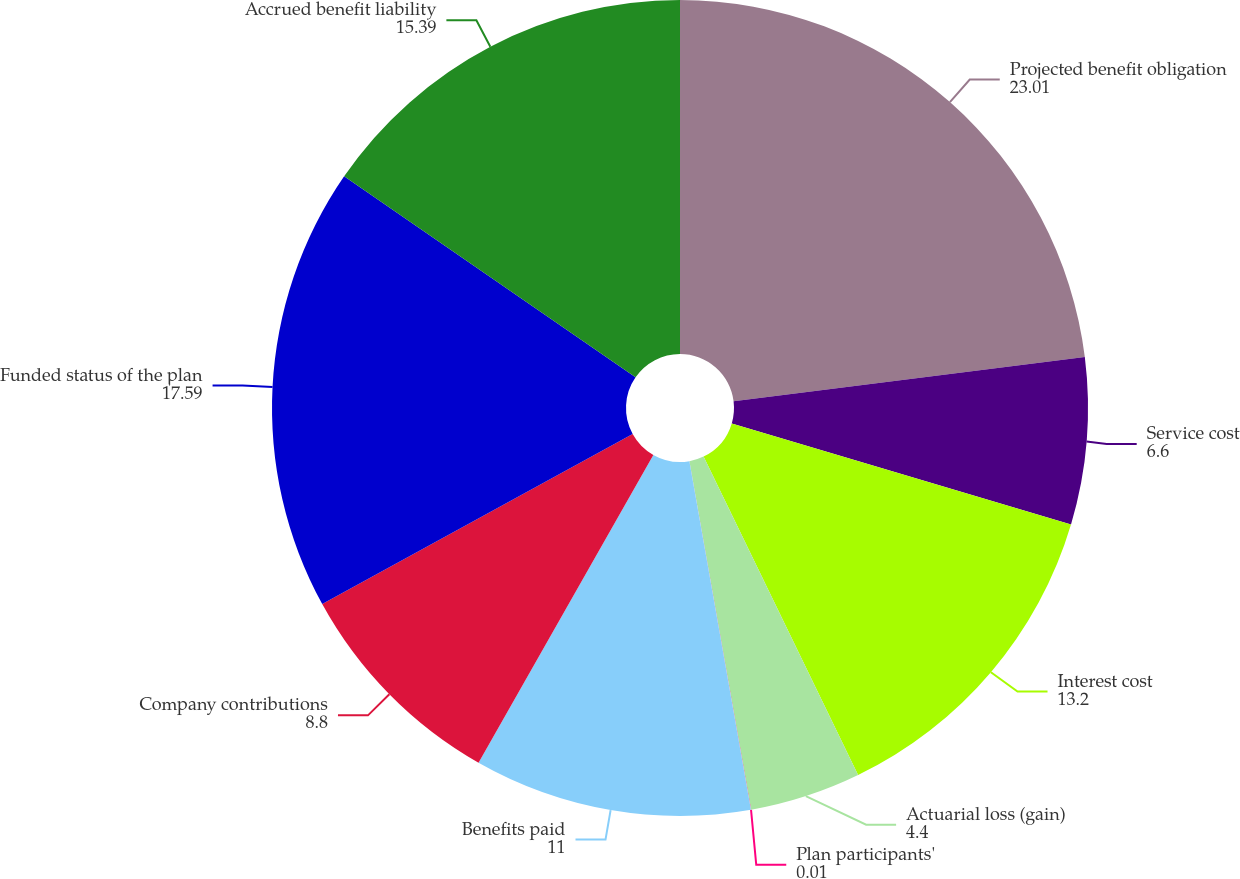<chart> <loc_0><loc_0><loc_500><loc_500><pie_chart><fcel>Projected benefit obligation<fcel>Service cost<fcel>Interest cost<fcel>Actuarial loss (gain)<fcel>Plan participants'<fcel>Benefits paid<fcel>Company contributions<fcel>Funded status of the plan<fcel>Accrued benefit liability<nl><fcel>23.01%<fcel>6.6%<fcel>13.2%<fcel>4.4%<fcel>0.01%<fcel>11.0%<fcel>8.8%<fcel>17.59%<fcel>15.39%<nl></chart> 